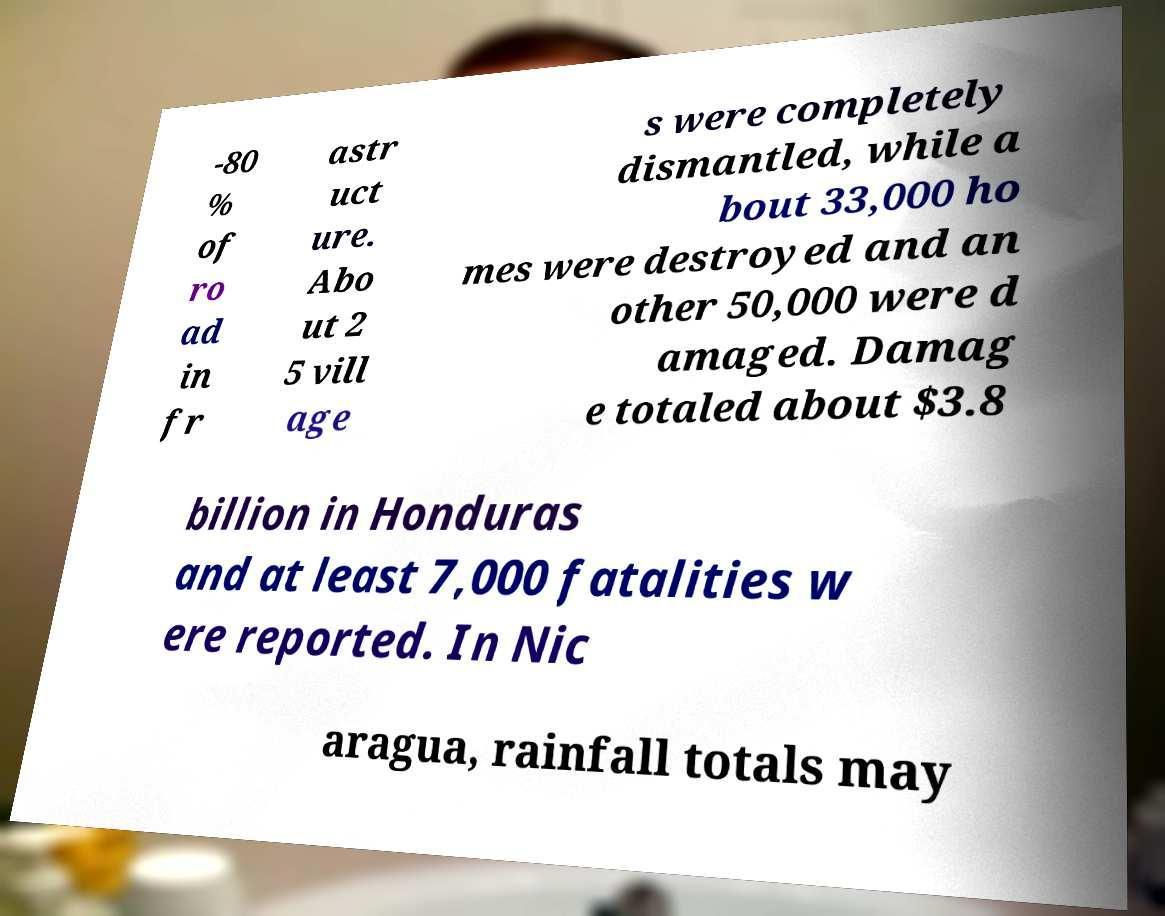Please identify and transcribe the text found in this image. -80 % of ro ad in fr astr uct ure. Abo ut 2 5 vill age s were completely dismantled, while a bout 33,000 ho mes were destroyed and an other 50,000 were d amaged. Damag e totaled about $3.8 billion in Honduras and at least 7,000 fatalities w ere reported. In Nic aragua, rainfall totals may 